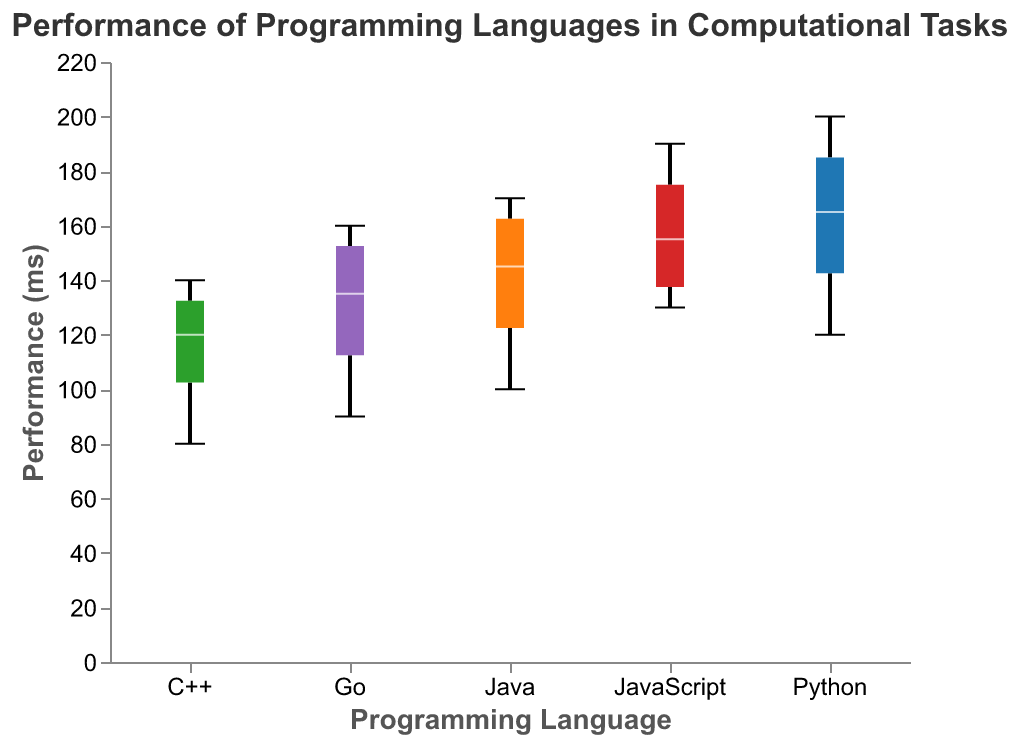What is the title of the plot? The title of the plot is placed at the top and it reads "Performance of Programming Languages in Computational Tasks".
Answer: Performance of Programming Languages in Computational Tasks Which language has the best (lowest) median performance across tasks? By looking at the horizontal lines within the boxes that represent the median, the lowest median line corresponds to C++.
Answer: C++ What is the range of performance times for Python in Sorting Algorithms? The boxplot for Python in Sorting Algorithms shows the minimum value (bottom line of the whisker) and maximum value (top line of the whisker), which are 120 ms and 120 ms, respectively.
Answer: 120 ms - 120 ms How does JavaScript's performance in Numerical Computation compare to Python's? By comparing the boxes for Numerical Computation under JavaScript and Python, JavaScript's box is higher on the y-axis, indicating higher performance times (worse performance) than Python.
Answer: Worse Which task shows the greatest variability for Java? Variability in a boxplot is shown by the height of the box. For Java, the tallest box (greatest vertical range) is for Numerical Computation.
Answer: Numerical Computation Is the median performance for Go in String Processing better or worse than Java in String Processing? The median is represented by the line within each box. Comparing the medians, Go's line is slightly lower than Java's, indicating Go's better performance.
Answer: Better What can you infer about the stability (consistency) of C++ performance across tasks? The box plot whiskers and boxes for C++ in various tasks are relatively short, indicating low variability and hence high consistency across tasks.
Answer: High Consistency What is the median performance for Python in Data Manipulation? The median is the horizontal line within the box for Python's Data Manipulation. This line is located at 180 ms.
Answer: 180 ms Which language shows the most consistent performance across different tasks based on boxplot variability? The boxes and whiskers for C++ are the shortest and most consistent across the different tasks, indicating the least variability in performance.
Answer: C++ 